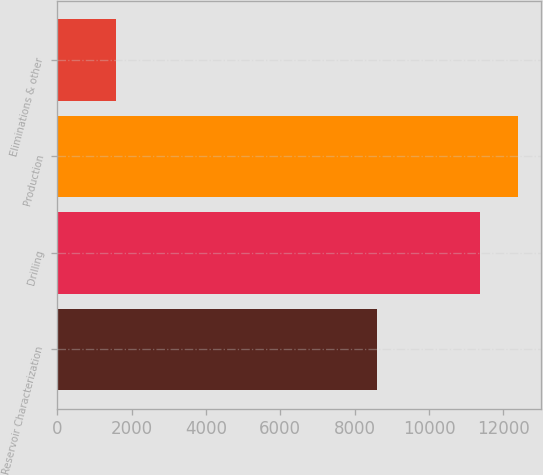<chart> <loc_0><loc_0><loc_500><loc_500><bar_chart><fcel>Reservoir Characterization<fcel>Drilling<fcel>Production<fcel>Eliminations & other<nl><fcel>8596<fcel>11378<fcel>12405.1<fcel>1577<nl></chart> 